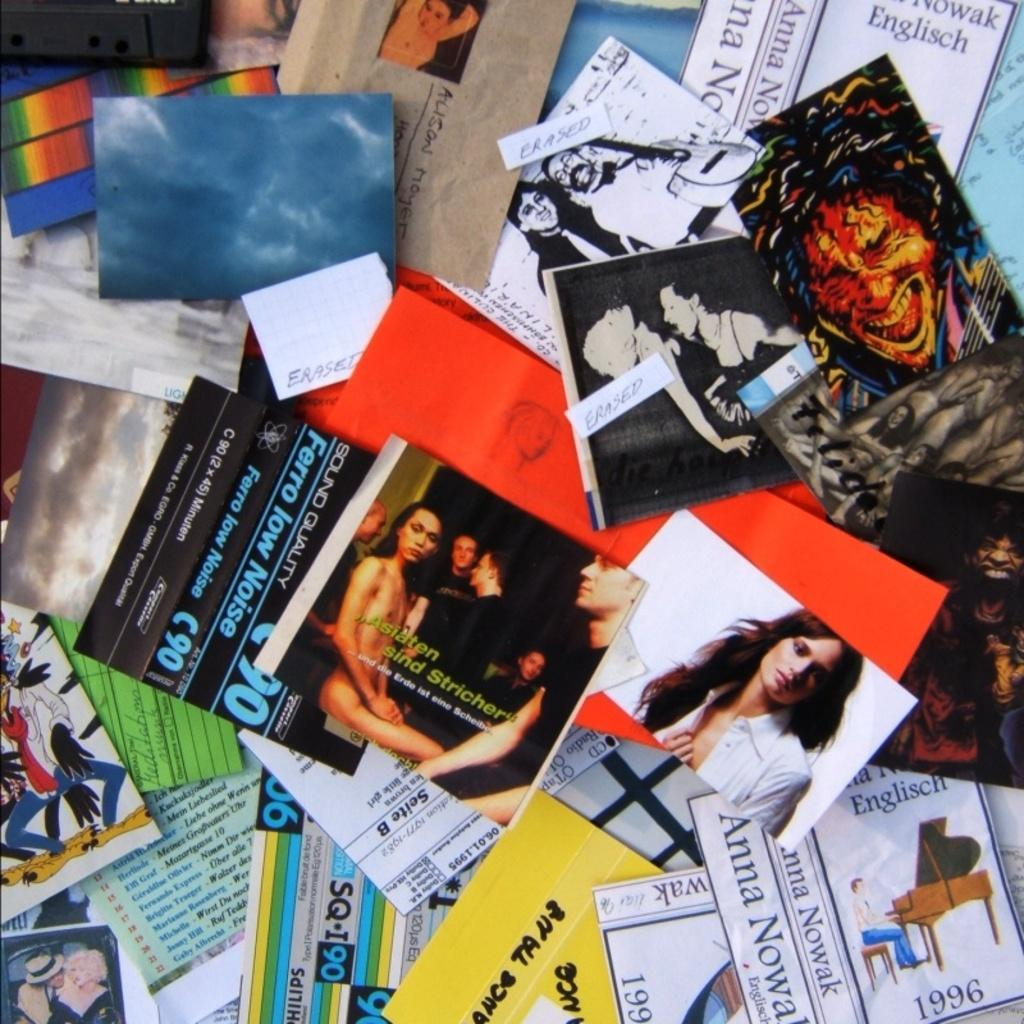<image>
Give a short and clear explanation of the subsequent image. Many album covers on a table including one from the year 1996. 